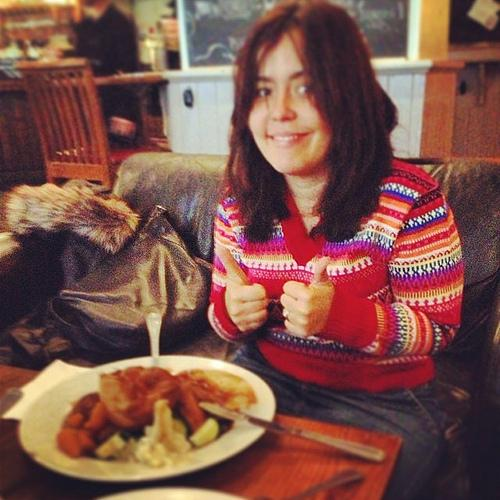Describe the scene in detail for a visual entailment task. The scene takes place in a restaurant, with a woman wearing a multicolored sweater and jeans, giving a thumbs up and smiling. She has brown hair and is seated at a wooden brown table with a chicken dinner, a spoon, knife, and a white plate. There is also a wooden chair, a handbag on a couch, and a black jacket with fur. Create a text describing the situation for a visual entailment task. A happy woman gives a thumbs-up in a restaurant, seated at a wooden table with a plate of food, knife, and spoon. A wooden chair, a black jacket with fur, and a purse on a couch are also present in the scene. Provide a concise product advertisement text based on the image. Dine in style and comfort with our beautiful wooden furniture set and elegant tableware, perfect for a happy night out or a cozy dinner at home. Provide a brief visual summary of the image for a multi-choice VQA task. A woman with brown hair and light skin is giving a thumbs up, smiling, and wearing a red sweater and jeans. There is a wooden table with food, a knife, spoon, and a white plate, in front of her. A wooden chair and a purse on a couch are also present in the scene. List the objects on the table and their characteristics for a multi-choice VQA task. There's a metallic knife, a metallic spoon, a white plate with food, and a wooden table. Mention three things focusing on the girl's appearance related to a referential expression grounding task. The girl has brown hair, she is wearing a red sweater, and she has light skin. Describe a complete outfit based on the image for a product advertisement task. Step out in confidence with our red multicolored sweater, comfortable jeans, and stylish handbag - perfect for a night out at your favorite restaurant or a casual gathering with friends. 